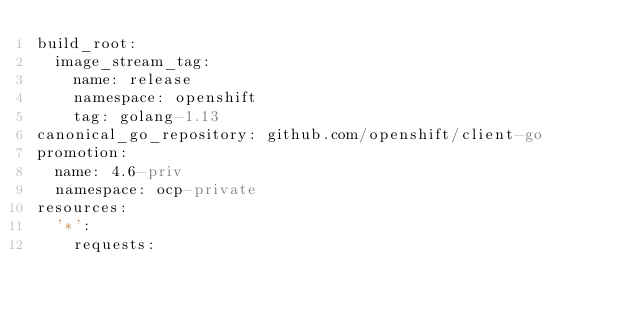<code> <loc_0><loc_0><loc_500><loc_500><_YAML_>build_root:
  image_stream_tag:
    name: release
    namespace: openshift
    tag: golang-1.13
canonical_go_repository: github.com/openshift/client-go
promotion:
  name: 4.6-priv
  namespace: ocp-private
resources:
  '*':
    requests:</code> 